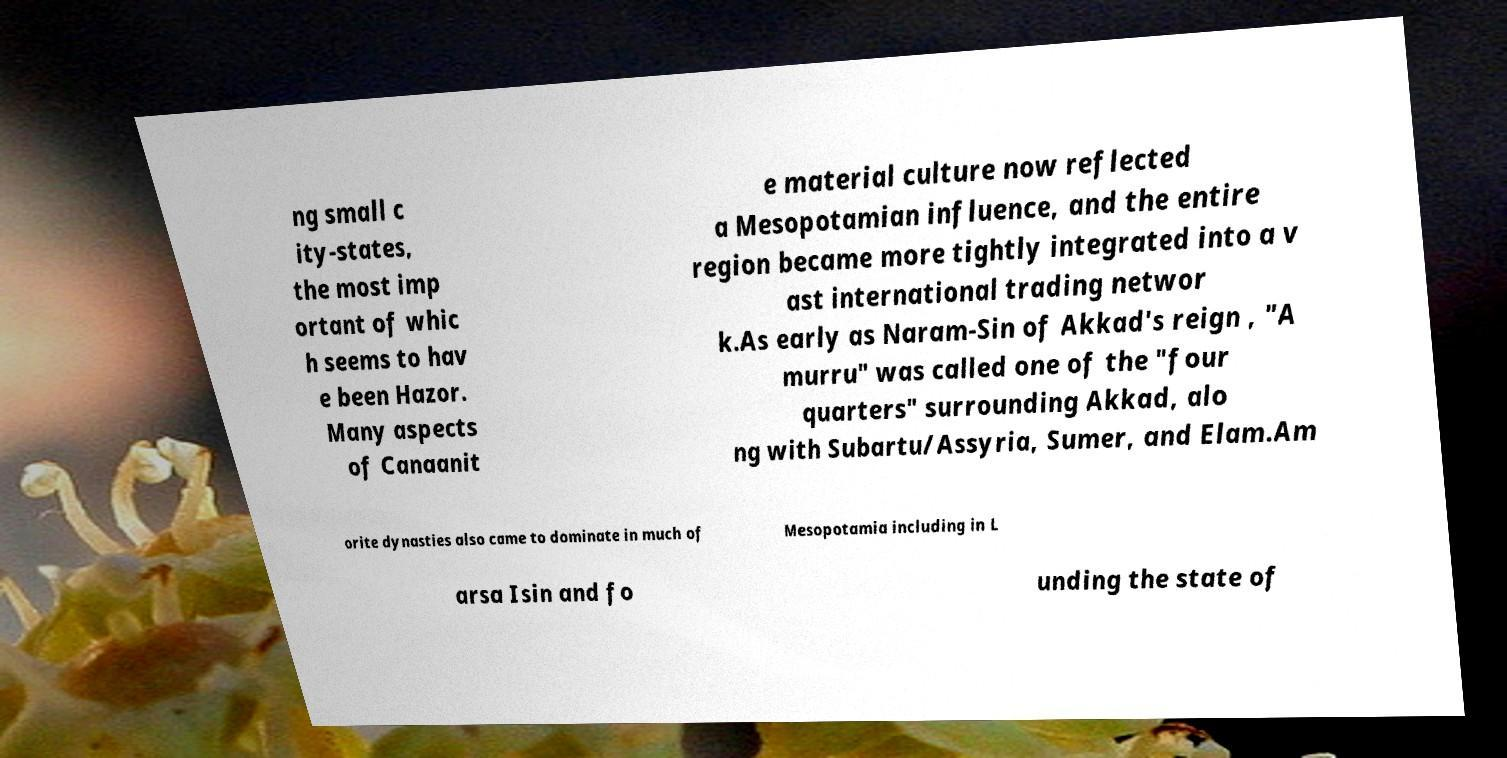Please identify and transcribe the text found in this image. ng small c ity-states, the most imp ortant of whic h seems to hav e been Hazor. Many aspects of Canaanit e material culture now reflected a Mesopotamian influence, and the entire region became more tightly integrated into a v ast international trading networ k.As early as Naram-Sin of Akkad's reign , "A murru" was called one of the "four quarters" surrounding Akkad, alo ng with Subartu/Assyria, Sumer, and Elam.Am orite dynasties also came to dominate in much of Mesopotamia including in L arsa Isin and fo unding the state of 